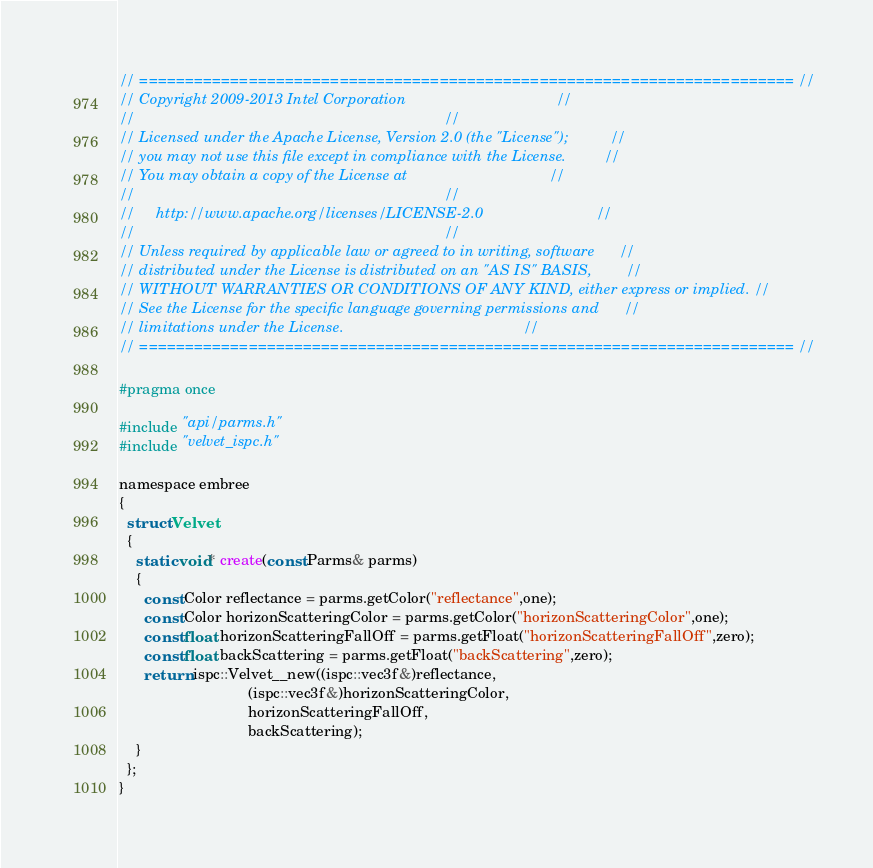Convert code to text. <code><loc_0><loc_0><loc_500><loc_500><_C_>// ======================================================================== //
// Copyright 2009-2013 Intel Corporation                                    //
//                                                                          //
// Licensed under the Apache License, Version 2.0 (the "License");          //
// you may not use this file except in compliance with the License.         //
// You may obtain a copy of the License at                                  //
//                                                                          //
//     http://www.apache.org/licenses/LICENSE-2.0                           //
//                                                                          //
// Unless required by applicable law or agreed to in writing, software      //
// distributed under the License is distributed on an "AS IS" BASIS,        //
// WITHOUT WARRANTIES OR CONDITIONS OF ANY KIND, either express or implied. //
// See the License for the specific language governing permissions and      //
// limitations under the License.                                           //
// ======================================================================== //

#pragma once

#include "api/parms.h"
#include "velvet_ispc.h"

namespace embree
{
  struct Velvet
  {
    static void* create(const Parms& parms)
    {
      const Color reflectance = parms.getColor("reflectance",one);
      const Color horizonScatteringColor = parms.getColor("horizonScatteringColor",one);
      const float horizonScatteringFallOff = parms.getFloat("horizonScatteringFallOff",zero);
      const float backScattering = parms.getFloat("backScattering",zero);
      return ispc::Velvet__new((ispc::vec3f&)reflectance,
                               (ispc::vec3f&)horizonScatteringColor,
                               horizonScatteringFallOff,
                               backScattering);
    }
  };
}

</code> 